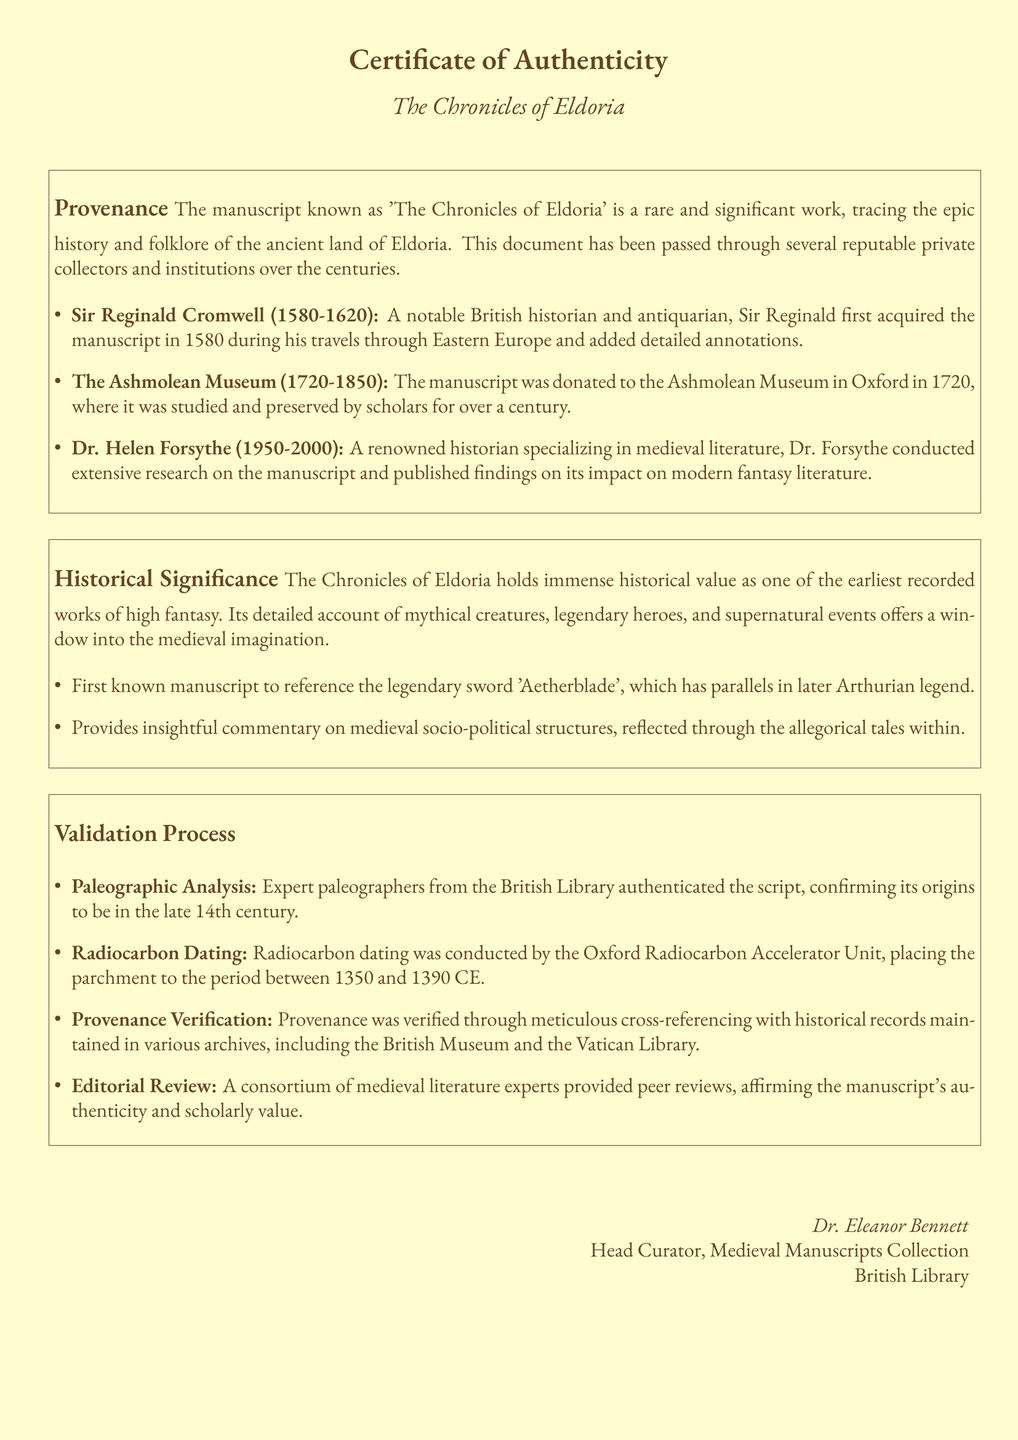What is the title of the manuscript? The title of the manuscript is mentioned at the top of the document in large text as "The Chronicles of Eldoria."
Answer: The Chronicles of Eldoria Who was the first owner of the manuscript? The first owner is outlined in the provenance section, and he is identified as Sir Reginald Cromwell.
Answer: Sir Reginald Cromwell In what year did the Ashmolean Museum acquire the manuscript? The document states that the manuscript was donated to the Ashmolean Museum in 1720.
Answer: 1720 What analysis was conducted to authenticate the script? The validation process section mentions paleographic analysis as a method for authentication.
Answer: Paleographic Analysis Who conducted radiocarbon dating on the manuscript? The radiocarbon dating was conducted by the Oxford Radiocarbon Accelerator Unit, as specified in the document.
Answer: Oxford Radiocarbon Accelerator Unit What is one significant feature of 'The Chronicles of Eldoria'? The historical significance section highlights that it is the first known manuscript to reference the legendary sword 'Aetherblade.'
Answer: Aetherblade How long did the Ashmolean Museum study the manuscript? According to the provenance section, the manuscript was studied at the Ashmolean Museum for over a century, implying approximately 130 years.
Answer: 130 years Who validated the manuscript through peer reviews? The document mentions a consortium of medieval literature experts as the group that provided peer reviews.
Answer: Consortium of medieval literature experts What is the role of Dr. Eleanor Bennett? The document identifies Dr. Eleanor Bennett as the Head Curator of the Medieval Manuscripts Collection at the British Library.
Answer: Head Curator 